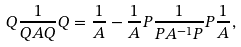Convert formula to latex. <formula><loc_0><loc_0><loc_500><loc_500>Q \frac { 1 } { Q A Q } Q = \frac { 1 } { A } - \frac { 1 } { A } P \frac { 1 } { P A ^ { - 1 } P } P \frac { 1 } { A } ,</formula> 